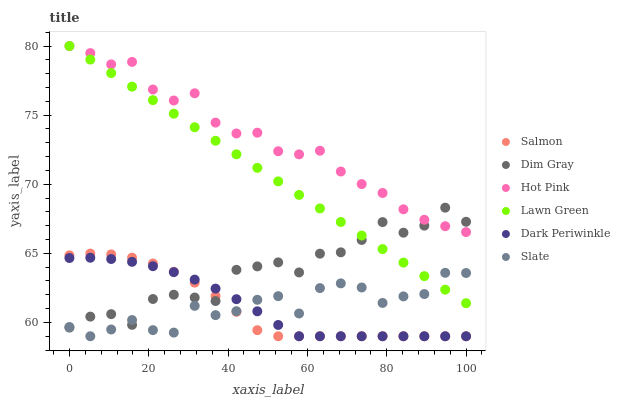Does Salmon have the minimum area under the curve?
Answer yes or no. Yes. Does Hot Pink have the maximum area under the curve?
Answer yes or no. Yes. Does Dim Gray have the minimum area under the curve?
Answer yes or no. No. Does Dim Gray have the maximum area under the curve?
Answer yes or no. No. Is Lawn Green the smoothest?
Answer yes or no. Yes. Is Dim Gray the roughest?
Answer yes or no. Yes. Is Slate the smoothest?
Answer yes or no. No. Is Slate the roughest?
Answer yes or no. No. Does Slate have the lowest value?
Answer yes or no. Yes. Does Dim Gray have the lowest value?
Answer yes or no. No. Does Hot Pink have the highest value?
Answer yes or no. Yes. Does Dim Gray have the highest value?
Answer yes or no. No. Is Salmon less than Hot Pink?
Answer yes or no. Yes. Is Hot Pink greater than Salmon?
Answer yes or no. Yes. Does Lawn Green intersect Slate?
Answer yes or no. Yes. Is Lawn Green less than Slate?
Answer yes or no. No. Is Lawn Green greater than Slate?
Answer yes or no. No. Does Salmon intersect Hot Pink?
Answer yes or no. No. 